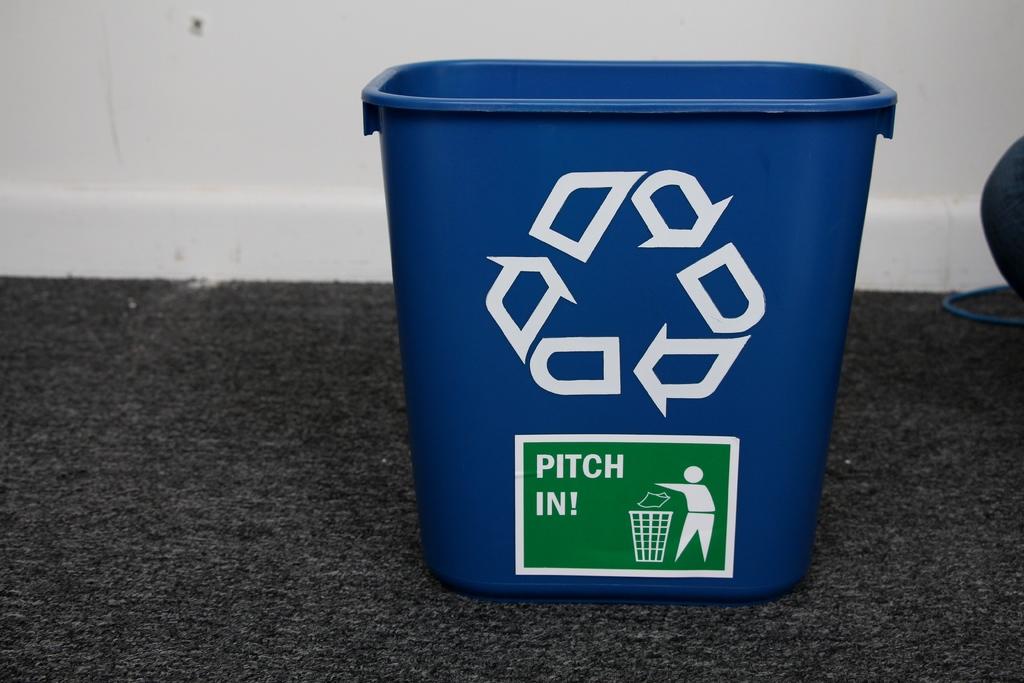What is on the green sticker?
Your response must be concise. Pitch in!. What is this box for?
Provide a succinct answer. Answering does not require reading text in the image. 